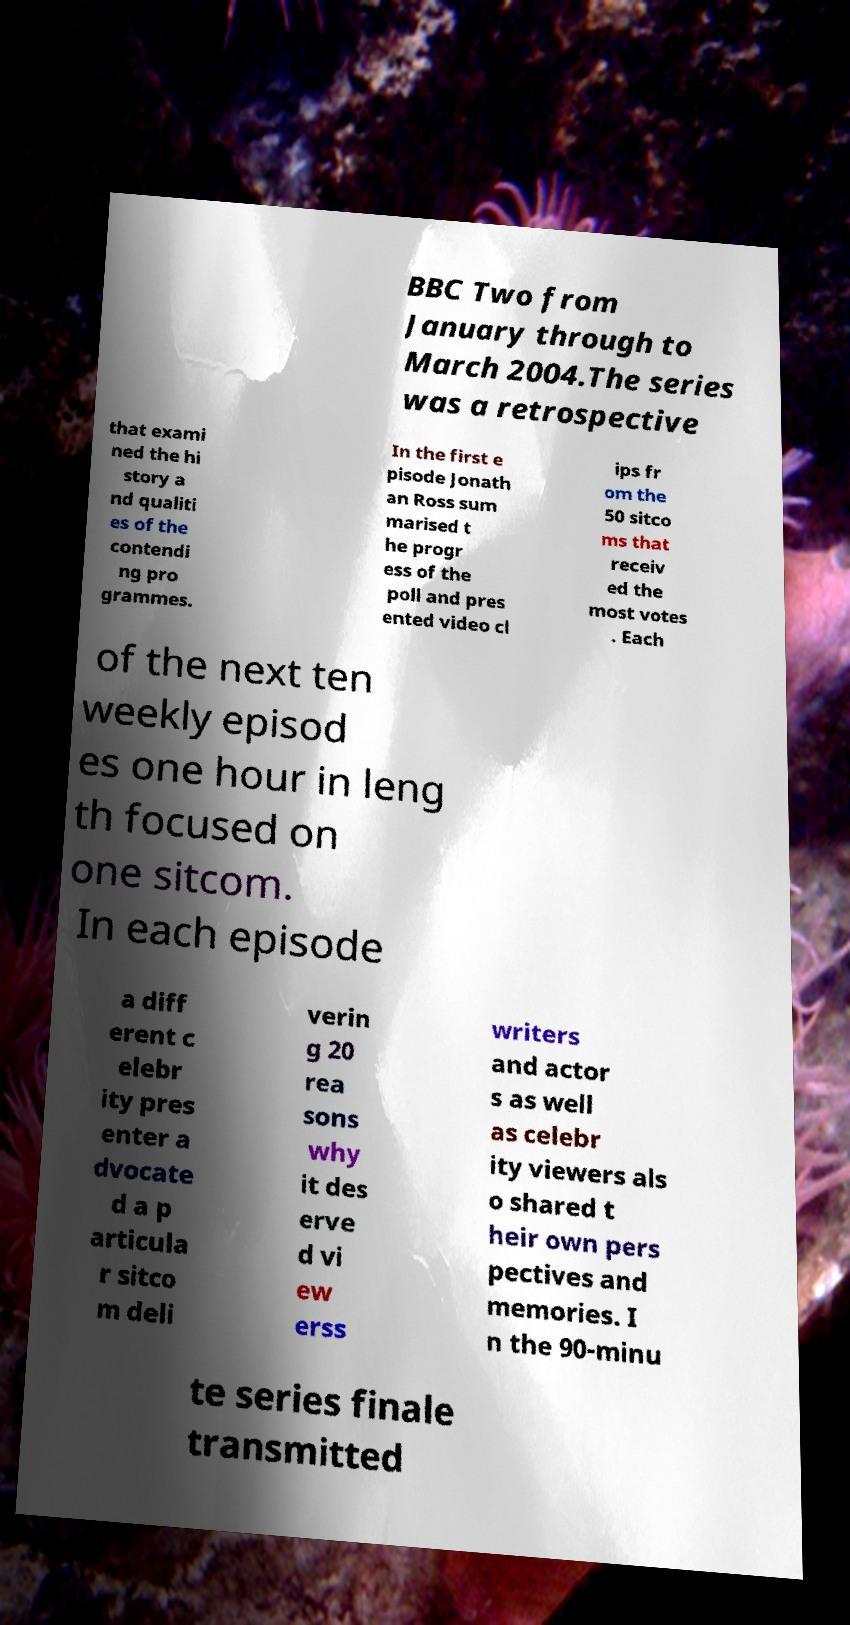Please identify and transcribe the text found in this image. BBC Two from January through to March 2004.The series was a retrospective that exami ned the hi story a nd qualiti es of the contendi ng pro grammes. In the first e pisode Jonath an Ross sum marised t he progr ess of the poll and pres ented video cl ips fr om the 50 sitco ms that receiv ed the most votes . Each of the next ten weekly episod es one hour in leng th focused on one sitcom. In each episode a diff erent c elebr ity pres enter a dvocate d a p articula r sitco m deli verin g 20 rea sons why it des erve d vi ew erss writers and actor s as well as celebr ity viewers als o shared t heir own pers pectives and memories. I n the 90-minu te series finale transmitted 